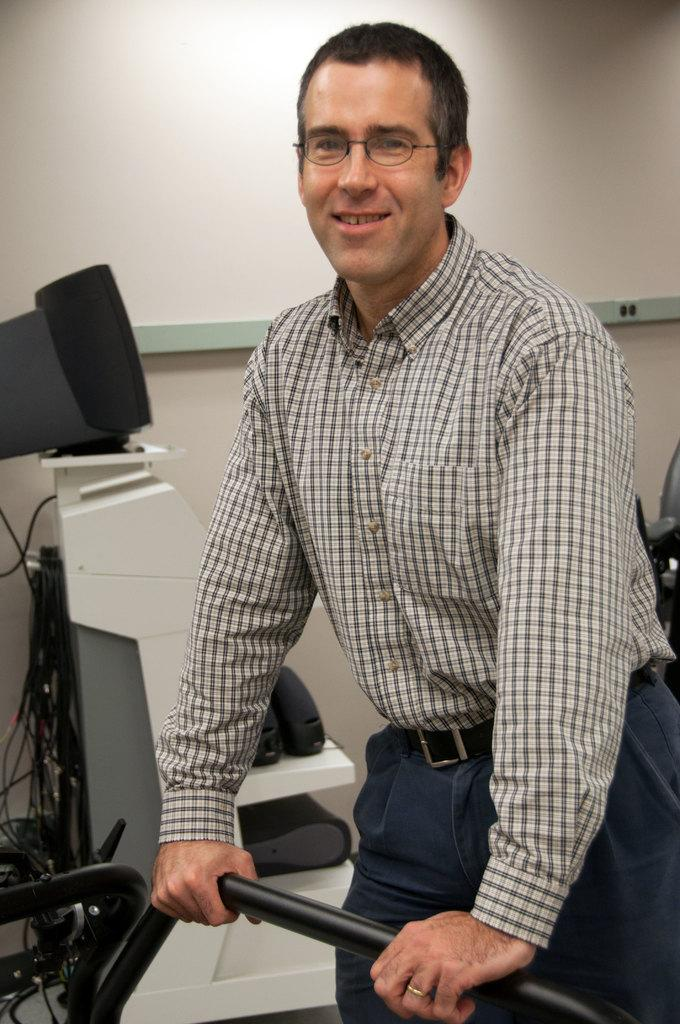What is the man in the image doing? The man is standing in the image. What object is the man holding? The man is holding a metal rod. What electronic device is present in the image? There is a monitor on a table on a table in the image. What type of furniture is visible in the image? There is a chair visible in the image. What type of leather is the monkey using to balance on the metal rod in the image? There is no monkey or leather present in the image. The man is holding a metal rod, but there is no monkey or balancing act depicted. 